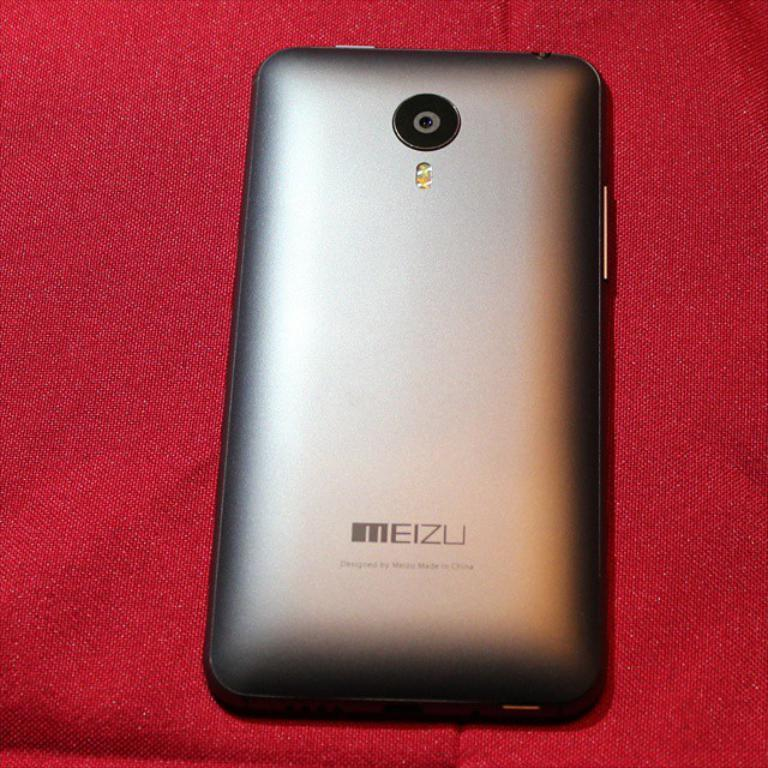<image>
Give a short and clear explanation of the subsequent image. the back of a MEIZU cell phone on a red backdrop 